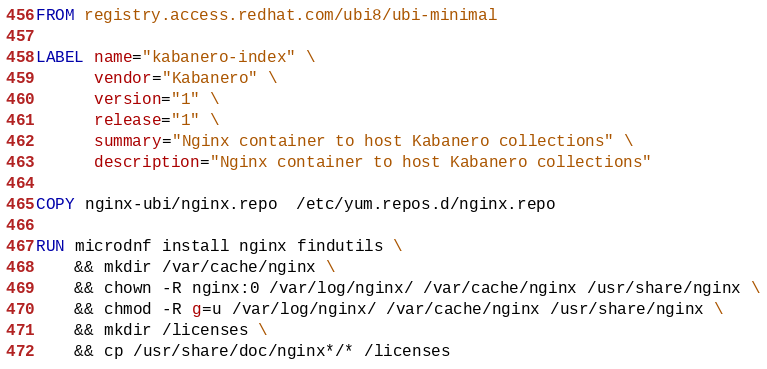Convert code to text. <code><loc_0><loc_0><loc_500><loc_500><_Dockerfile_>FROM registry.access.redhat.com/ubi8/ubi-minimal

LABEL name="kabanero-index" \
      vendor="Kabanero" \
      version="1" \
      release="1" \
      summary="Nginx container to host Kabanero collections" \
      description="Nginx container to host Kabanero collections"

COPY nginx-ubi/nginx.repo  /etc/yum.repos.d/nginx.repo

RUN microdnf install nginx findutils \
    && mkdir /var/cache/nginx \
    && chown -R nginx:0 /var/log/nginx/ /var/cache/nginx /usr/share/nginx \
    && chmod -R g=u /var/log/nginx/ /var/cache/nginx /usr/share/nginx \
    && mkdir /licenses \
    && cp /usr/share/doc/nginx*/* /licenses
</code> 